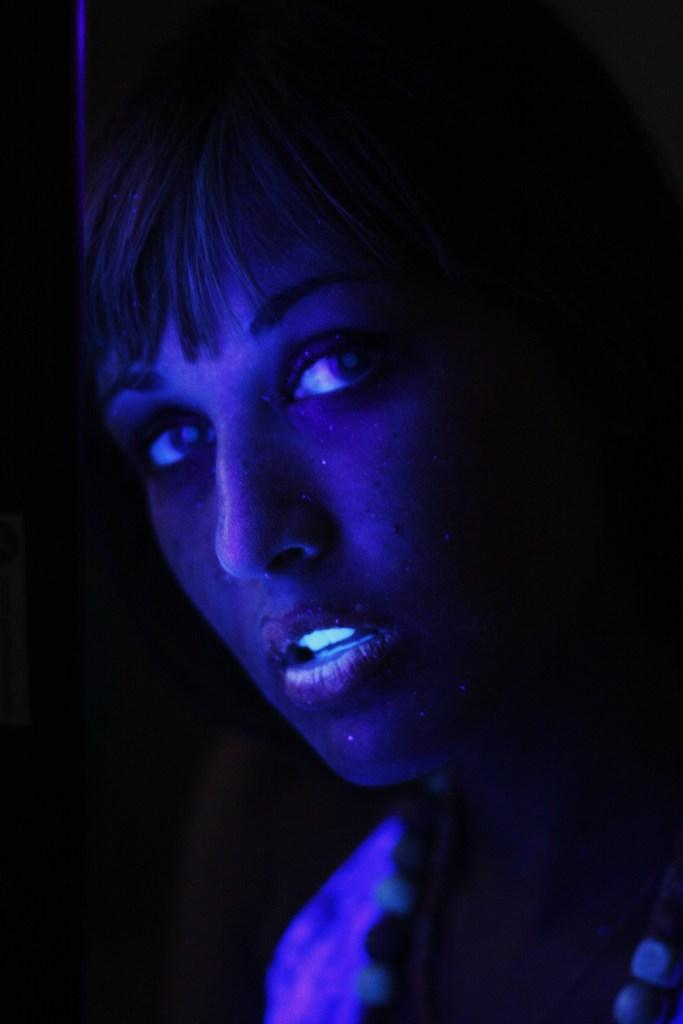Who is the main subject in the image? There is a woman in the image. What is unique about the woman's appearance? The woman's body is painted with radium. What can be observed about the lighting in the image? There is darkness on the left side of the image. What type of juice is being served on the train in the image? There is no train or juice present in the image; it features a woman with radium paint on her body and darkness on the left side. 